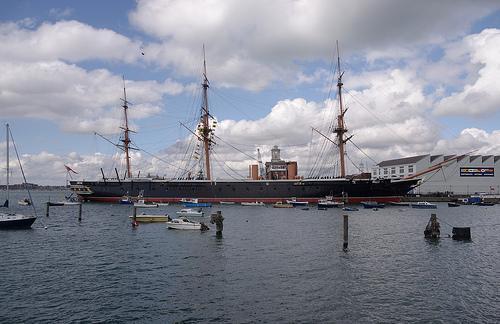How many small boats are in the front photo?
Give a very brief answer. 4. How many smaller ships can be seen?
Give a very brief answer. 8. 